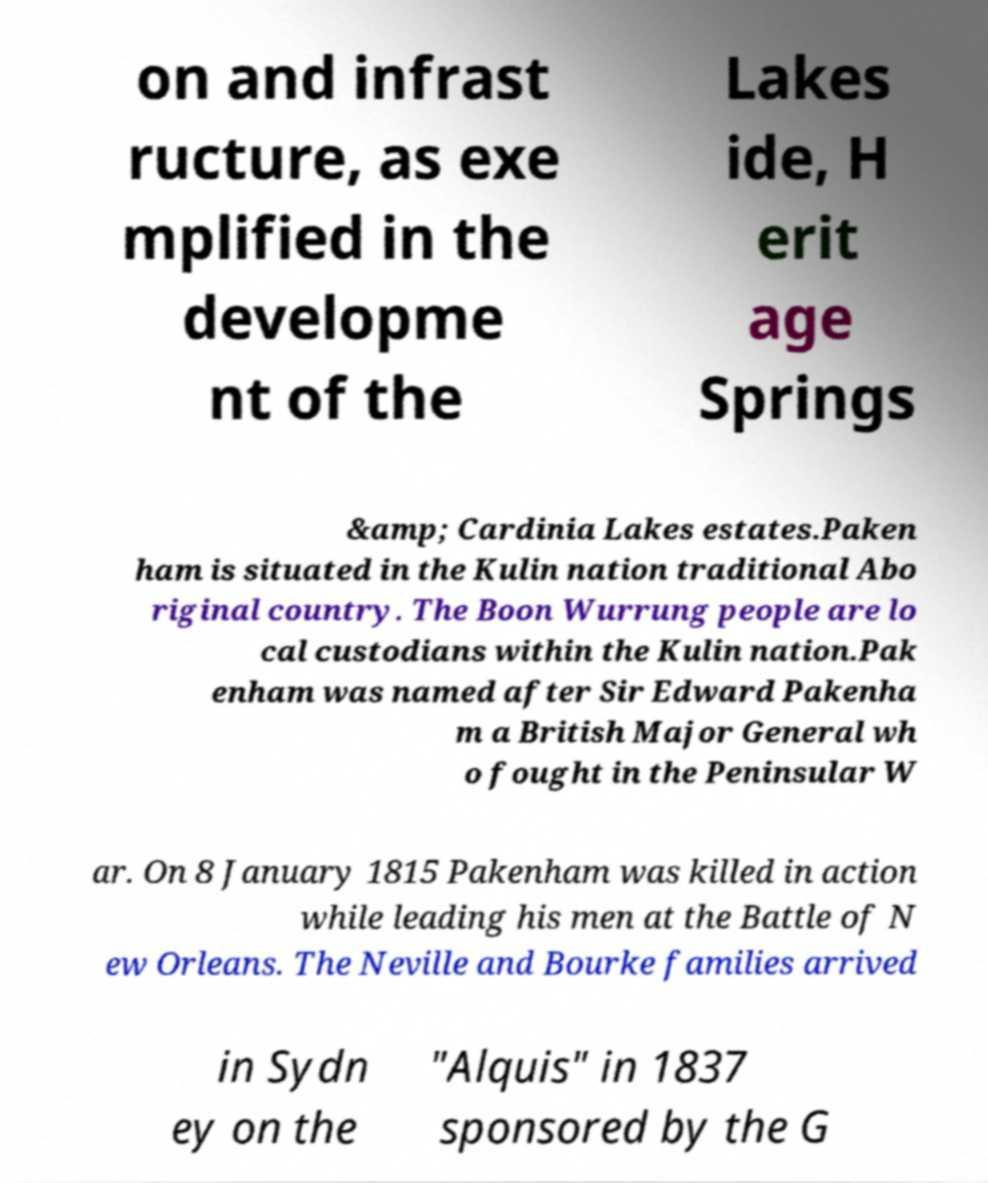I need the written content from this picture converted into text. Can you do that? on and infrast ructure, as exe mplified in the developme nt of the Lakes ide, H erit age Springs &amp; Cardinia Lakes estates.Paken ham is situated in the Kulin nation traditional Abo riginal country. The Boon Wurrung people are lo cal custodians within the Kulin nation.Pak enham was named after Sir Edward Pakenha m a British Major General wh o fought in the Peninsular W ar. On 8 January 1815 Pakenham was killed in action while leading his men at the Battle of N ew Orleans. The Neville and Bourke families arrived in Sydn ey on the "Alquis" in 1837 sponsored by the G 